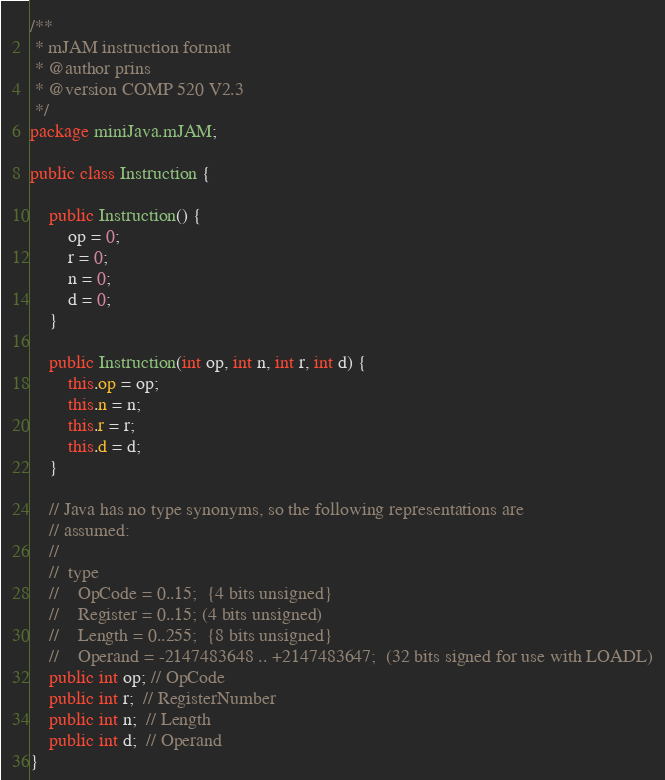<code> <loc_0><loc_0><loc_500><loc_500><_Java_>/**
 * mJAM instruction format
 * @author prins
 * @version COMP 520 V2.3
 */
package miniJava.mJAM;

public class Instruction {

	public Instruction() {
		op = 0;
		r = 0;
		n = 0;
		d = 0;
	}

	public Instruction(int op, int n, int r, int d) {
		this.op = op;
		this.n = n;
		this.r = r;
		this.d = d;
	}

	// Java has no type synonyms, so the following representations are
	// assumed:
	//
	//  type
	//    OpCode = 0..15;  {4 bits unsigned}
	//    Register = 0..15; (4 bits unsigned)
	//    Length = 0..255;  {8 bits unsigned}
	//    Operand = -2147483648 .. +2147483647;  (32 bits signed for use with LOADL)
	public int op; // OpCode
	public int r;  // RegisterNumber
	public int n;  // Length
	public int d;  // Operand
}
</code> 